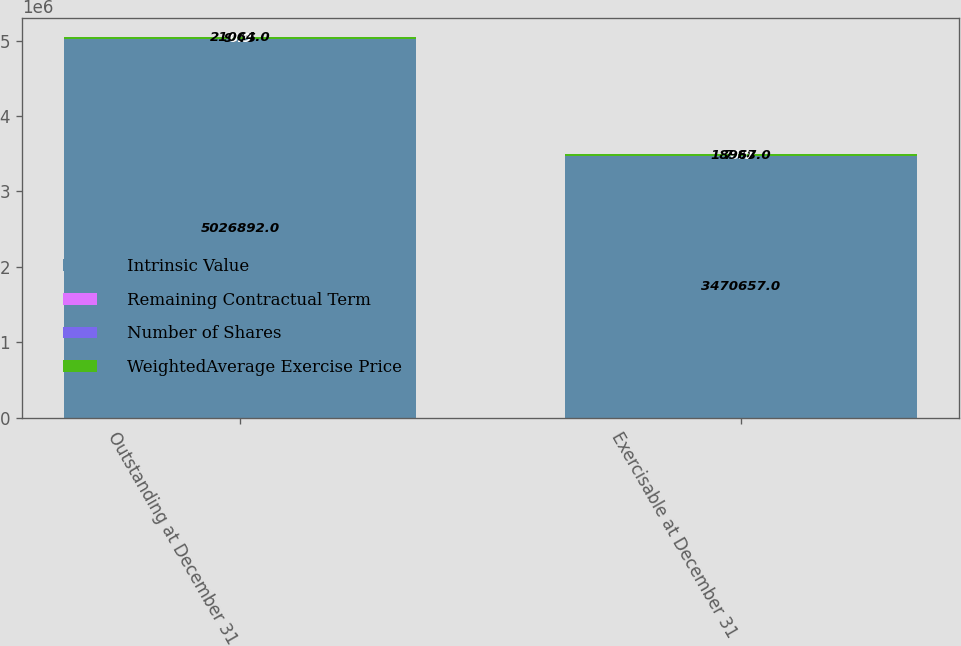Convert chart to OTSL. <chart><loc_0><loc_0><loc_500><loc_500><stacked_bar_chart><ecel><fcel>Outstanding at December 31<fcel>Exercisable at December 31<nl><fcel>Intrinsic Value<fcel>5.02689e+06<fcel>3.47066e+06<nl><fcel>Remaining Contractual Term<fcel>9.05<fcel>7.88<nl><fcel>Number of Shares<fcel>6.9<fcel>6<nl><fcel>WeightedAverage Exercise Price<fcel>21064<fcel>18967<nl></chart> 